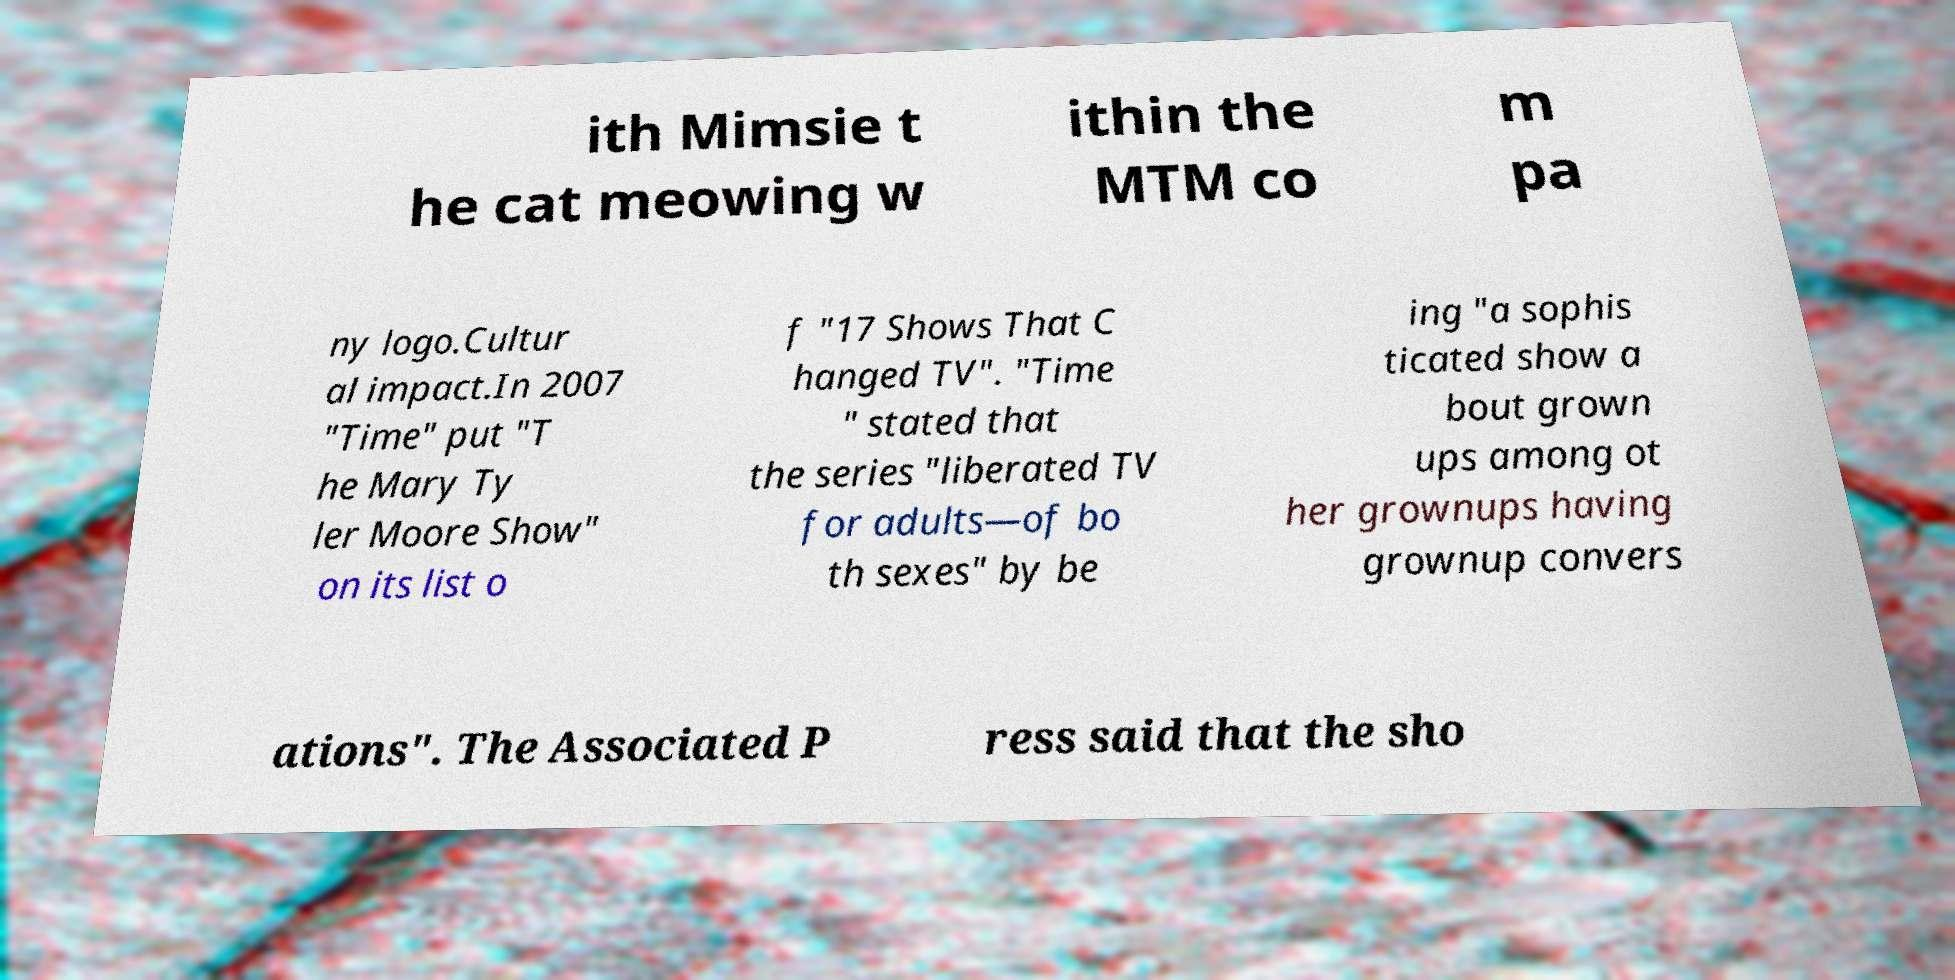Can you accurately transcribe the text from the provided image for me? ith Mimsie t he cat meowing w ithin the MTM co m pa ny logo.Cultur al impact.In 2007 "Time" put "T he Mary Ty ler Moore Show" on its list o f "17 Shows That C hanged TV". "Time " stated that the series "liberated TV for adults—of bo th sexes" by be ing "a sophis ticated show a bout grown ups among ot her grownups having grownup convers ations". The Associated P ress said that the sho 